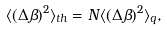<formula> <loc_0><loc_0><loc_500><loc_500>\langle ( \Delta { \beta } ) ^ { 2 } \rangle _ { t h } = N \langle ( \Delta { \beta } ) ^ { 2 } \rangle _ { q } ,</formula> 